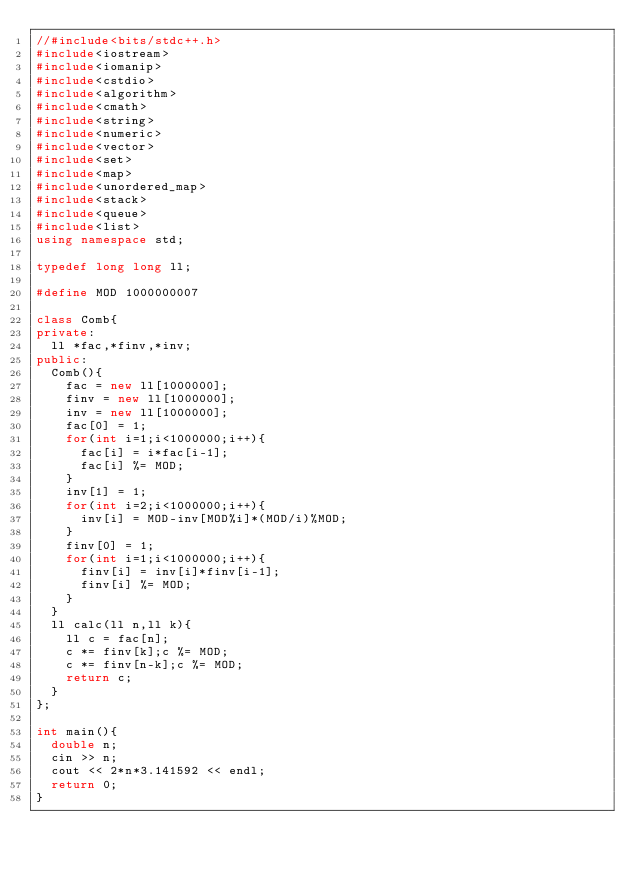<code> <loc_0><loc_0><loc_500><loc_500><_C++_>//#include<bits/stdc++.h>
#include<iostream>
#include<iomanip>
#include<cstdio>
#include<algorithm>
#include<cmath>
#include<string>
#include<numeric>
#include<vector>
#include<set>
#include<map>
#include<unordered_map>
#include<stack>
#include<queue>
#include<list>
using namespace std;

typedef long long ll;

#define MOD 1000000007

class Comb{
private:
  ll *fac,*finv,*inv;
public:
  Comb(){
    fac = new ll[1000000];
    finv = new ll[1000000];
    inv = new ll[1000000];
    fac[0] = 1;
    for(int i=1;i<1000000;i++){
      fac[i] = i*fac[i-1];
      fac[i] %= MOD;
    }
    inv[1] = 1;
    for(int i=2;i<1000000;i++){
      inv[i] = MOD-inv[MOD%i]*(MOD/i)%MOD;
    }
    finv[0] = 1;
    for(int i=1;i<1000000;i++){
      finv[i] = inv[i]*finv[i-1];
      finv[i] %= MOD;
    }
  }
  ll calc(ll n,ll k){
    ll c = fac[n];
    c *= finv[k];c %= MOD;
    c *= finv[n-k];c %= MOD;
    return c;
  }
};

int main(){
  double n;
  cin >> n;
  cout << 2*n*3.141592 << endl;
  return 0;
}
</code> 